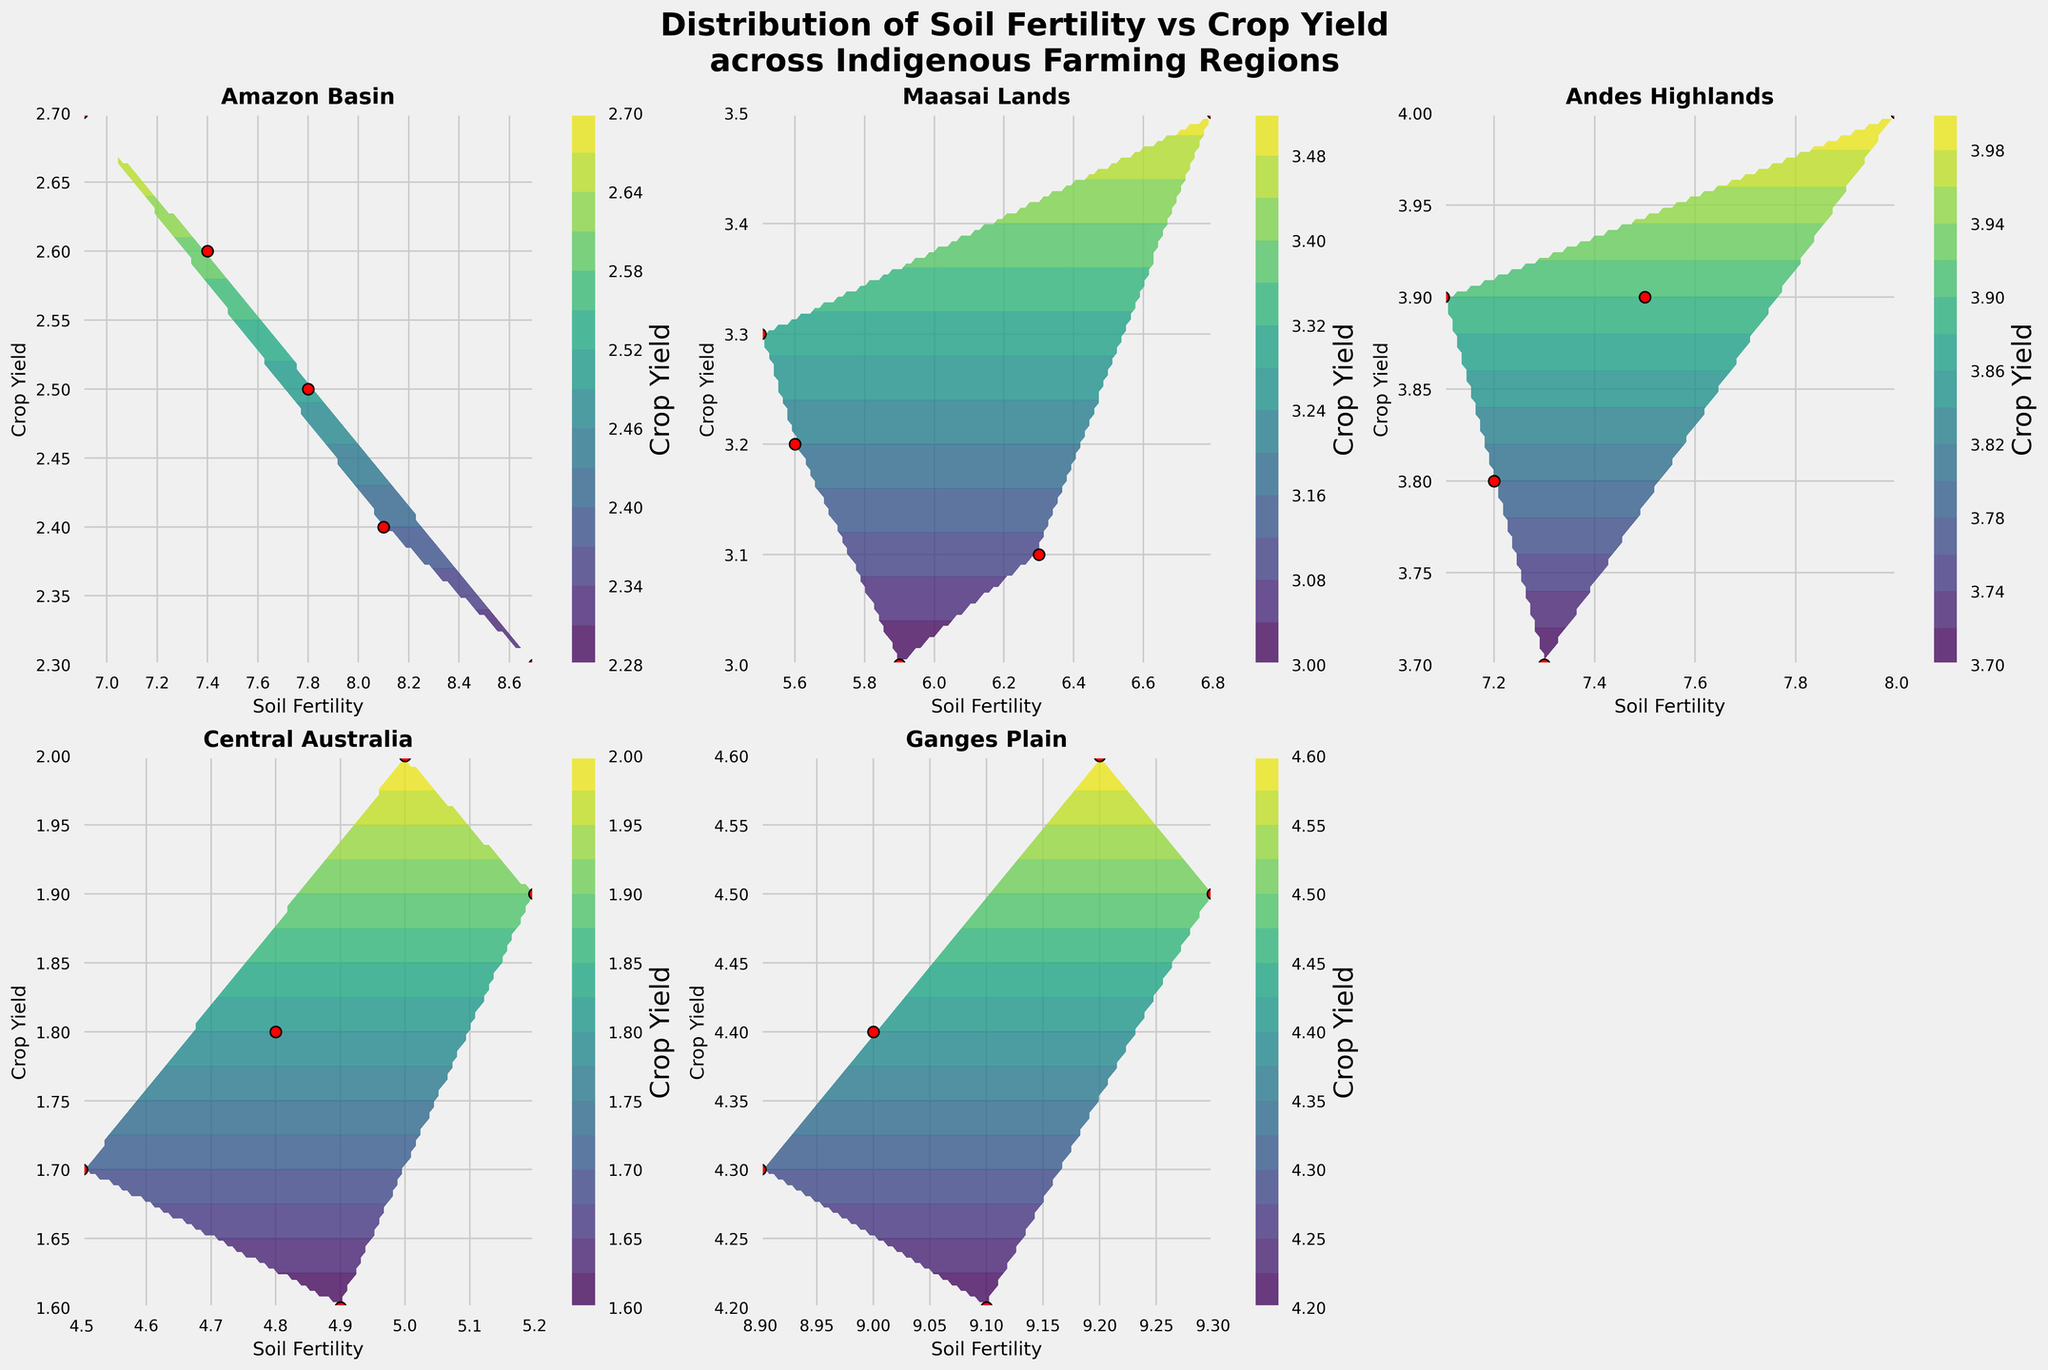What is the title of the figure? The title is located at the top center of the figure, which describes the main subject of the plots.
Answer: Distribution of Soil Fertility vs Crop Yield across Indigenous Farming Regions How many indigenous farming regions are compared in the figure? There are six subplots in the figure, each representing a different indigenous farming region.
Answer: Six Which region has the highest value of soil fertility? By visually inspecting the x-axis of each subplot, the Ganges Plain has the highest soil fertility values.
Answer: Ganges Plain How does the crop yield in Central Australia compare to other regions? Central Australia shows lower crop yield values across the scatter points and contour plots compared to other regions.
Answer: Lower What is the general trend between soil fertility and crop yield in the Amazon Basin? The scatter points and the contour lines suggest that as soil fertility increases, the crop yield also slightly increases.
Answer: Positive correlation Which region has the widest spread of soil fertility values? The region with the widest spread of soil fertility values can be determined by observing the range on the x-axis. The Ganges Plain spans from approximately 8.9 to 9.3.
Answer: Ganges Plain In which region does crop yield have the highest average value? By analyzing the y-axis values and the contour peaks, the Ganges Plain shows the highest average crop yield values.
Answer: Ganges Plain What does the color gradient in the contour plots represent? The color gradient in the contour plots represents crop yield values, with different shades indicating different levels.
Answer: Crop yield Which region shows a negative correlation between soil fertility and crop yield, if any? By examining the scatter points and contour plots, no region appears to show a negative correlation. All regions show either positive correlation or no clear correlation.
Answer: None Which region has the point with the lowest crop yield? By looking at the scatter points of each subplot, Central Australia has the point with the lowest crop yield at approximately 1.6.
Answer: Central Australia 